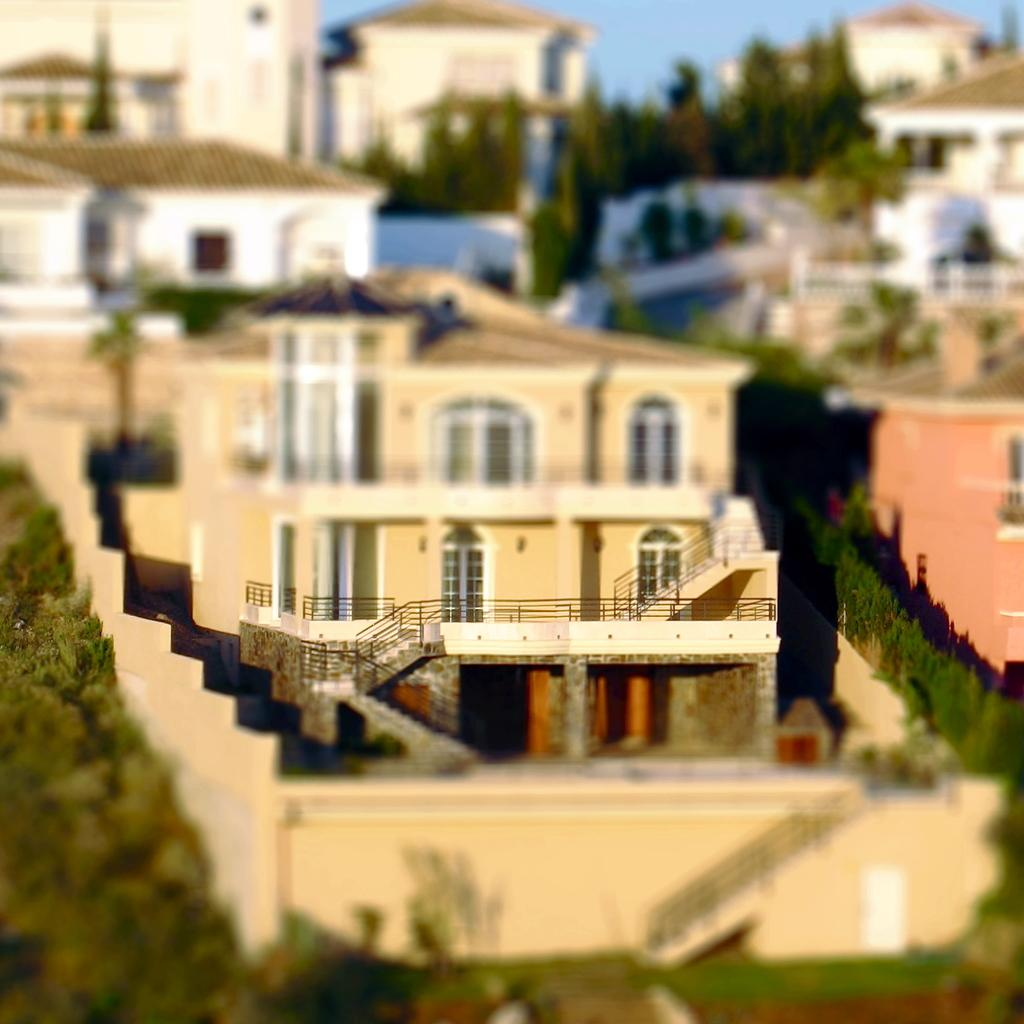What type of structures can be seen in the image? There are buildings in the image. What is present between the buildings? There are trees between the buildings. What can be seen in the background of the image? The sky is visible in the background of the image. How many cherries are on the shelf in the image? There is no shelf or cherries present in the image. 